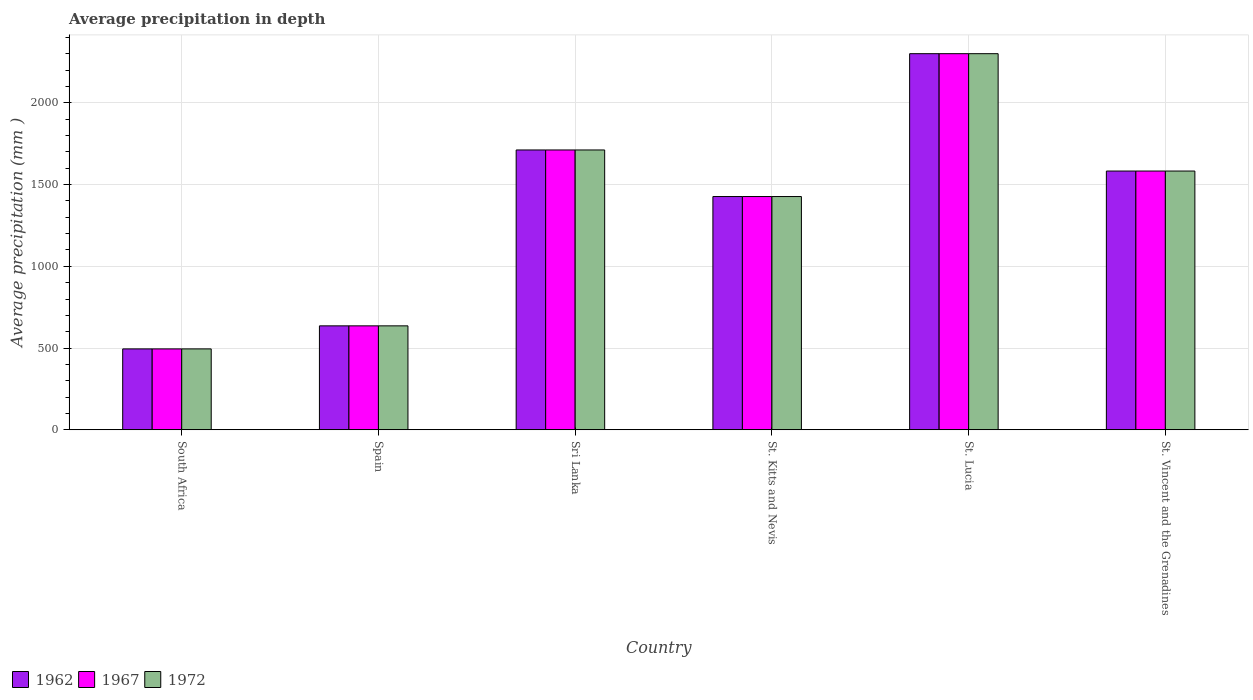How many different coloured bars are there?
Give a very brief answer. 3. How many bars are there on the 6th tick from the left?
Offer a terse response. 3. How many bars are there on the 3rd tick from the right?
Your answer should be compact. 3. What is the label of the 1st group of bars from the left?
Make the answer very short. South Africa. In how many cases, is the number of bars for a given country not equal to the number of legend labels?
Give a very brief answer. 0. What is the average precipitation in 1967 in Sri Lanka?
Provide a succinct answer. 1712. Across all countries, what is the maximum average precipitation in 1967?
Your response must be concise. 2301. Across all countries, what is the minimum average precipitation in 1972?
Ensure brevity in your answer.  495. In which country was the average precipitation in 1967 maximum?
Ensure brevity in your answer.  St. Lucia. In which country was the average precipitation in 1962 minimum?
Your answer should be compact. South Africa. What is the total average precipitation in 1972 in the graph?
Ensure brevity in your answer.  8154. What is the difference between the average precipitation in 1972 in South Africa and that in St. Lucia?
Keep it short and to the point. -1806. What is the difference between the average precipitation in 1967 in St. Vincent and the Grenadines and the average precipitation in 1972 in Spain?
Offer a terse response. 947. What is the average average precipitation in 1962 per country?
Provide a succinct answer. 1359. In how many countries, is the average precipitation in 1967 greater than 300 mm?
Provide a short and direct response. 6. What is the ratio of the average precipitation in 1967 in St. Lucia to that in St. Vincent and the Grenadines?
Your answer should be compact. 1.45. Is the difference between the average precipitation in 1972 in South Africa and Spain greater than the difference between the average precipitation in 1967 in South Africa and Spain?
Give a very brief answer. No. What is the difference between the highest and the second highest average precipitation in 1962?
Provide a short and direct response. -589. What is the difference between the highest and the lowest average precipitation in 1962?
Make the answer very short. 1806. Is the sum of the average precipitation in 1962 in Sri Lanka and St. Kitts and Nevis greater than the maximum average precipitation in 1967 across all countries?
Give a very brief answer. Yes. What does the 2nd bar from the right in St. Kitts and Nevis represents?
Your answer should be very brief. 1967. Is it the case that in every country, the sum of the average precipitation in 1962 and average precipitation in 1972 is greater than the average precipitation in 1967?
Provide a succinct answer. Yes. How many bars are there?
Provide a succinct answer. 18. Are all the bars in the graph horizontal?
Your answer should be compact. No. How many countries are there in the graph?
Your answer should be compact. 6. What is the difference between two consecutive major ticks on the Y-axis?
Make the answer very short. 500. Does the graph contain any zero values?
Give a very brief answer. No. Where does the legend appear in the graph?
Offer a very short reply. Bottom left. What is the title of the graph?
Offer a terse response. Average precipitation in depth. Does "1987" appear as one of the legend labels in the graph?
Make the answer very short. No. What is the label or title of the X-axis?
Ensure brevity in your answer.  Country. What is the label or title of the Y-axis?
Offer a terse response. Average precipitation (mm ). What is the Average precipitation (mm ) in 1962 in South Africa?
Provide a short and direct response. 495. What is the Average precipitation (mm ) in 1967 in South Africa?
Your answer should be compact. 495. What is the Average precipitation (mm ) in 1972 in South Africa?
Offer a very short reply. 495. What is the Average precipitation (mm ) of 1962 in Spain?
Your response must be concise. 636. What is the Average precipitation (mm ) in 1967 in Spain?
Ensure brevity in your answer.  636. What is the Average precipitation (mm ) of 1972 in Spain?
Keep it short and to the point. 636. What is the Average precipitation (mm ) of 1962 in Sri Lanka?
Keep it short and to the point. 1712. What is the Average precipitation (mm ) of 1967 in Sri Lanka?
Provide a short and direct response. 1712. What is the Average precipitation (mm ) of 1972 in Sri Lanka?
Offer a very short reply. 1712. What is the Average precipitation (mm ) in 1962 in St. Kitts and Nevis?
Keep it short and to the point. 1427. What is the Average precipitation (mm ) in 1967 in St. Kitts and Nevis?
Give a very brief answer. 1427. What is the Average precipitation (mm ) of 1972 in St. Kitts and Nevis?
Provide a succinct answer. 1427. What is the Average precipitation (mm ) of 1962 in St. Lucia?
Give a very brief answer. 2301. What is the Average precipitation (mm ) of 1967 in St. Lucia?
Your answer should be compact. 2301. What is the Average precipitation (mm ) in 1972 in St. Lucia?
Your answer should be compact. 2301. What is the Average precipitation (mm ) of 1962 in St. Vincent and the Grenadines?
Your answer should be very brief. 1583. What is the Average precipitation (mm ) in 1967 in St. Vincent and the Grenadines?
Make the answer very short. 1583. What is the Average precipitation (mm ) of 1972 in St. Vincent and the Grenadines?
Your response must be concise. 1583. Across all countries, what is the maximum Average precipitation (mm ) of 1962?
Your response must be concise. 2301. Across all countries, what is the maximum Average precipitation (mm ) of 1967?
Offer a very short reply. 2301. Across all countries, what is the maximum Average precipitation (mm ) of 1972?
Give a very brief answer. 2301. Across all countries, what is the minimum Average precipitation (mm ) in 1962?
Offer a very short reply. 495. Across all countries, what is the minimum Average precipitation (mm ) of 1967?
Make the answer very short. 495. Across all countries, what is the minimum Average precipitation (mm ) in 1972?
Offer a terse response. 495. What is the total Average precipitation (mm ) of 1962 in the graph?
Provide a short and direct response. 8154. What is the total Average precipitation (mm ) in 1967 in the graph?
Make the answer very short. 8154. What is the total Average precipitation (mm ) of 1972 in the graph?
Ensure brevity in your answer.  8154. What is the difference between the Average precipitation (mm ) of 1962 in South Africa and that in Spain?
Offer a very short reply. -141. What is the difference between the Average precipitation (mm ) in 1967 in South Africa and that in Spain?
Provide a short and direct response. -141. What is the difference between the Average precipitation (mm ) of 1972 in South Africa and that in Spain?
Give a very brief answer. -141. What is the difference between the Average precipitation (mm ) in 1962 in South Africa and that in Sri Lanka?
Offer a terse response. -1217. What is the difference between the Average precipitation (mm ) of 1967 in South Africa and that in Sri Lanka?
Your answer should be very brief. -1217. What is the difference between the Average precipitation (mm ) in 1972 in South Africa and that in Sri Lanka?
Provide a succinct answer. -1217. What is the difference between the Average precipitation (mm ) of 1962 in South Africa and that in St. Kitts and Nevis?
Give a very brief answer. -932. What is the difference between the Average precipitation (mm ) in 1967 in South Africa and that in St. Kitts and Nevis?
Give a very brief answer. -932. What is the difference between the Average precipitation (mm ) of 1972 in South Africa and that in St. Kitts and Nevis?
Your response must be concise. -932. What is the difference between the Average precipitation (mm ) of 1962 in South Africa and that in St. Lucia?
Make the answer very short. -1806. What is the difference between the Average precipitation (mm ) of 1967 in South Africa and that in St. Lucia?
Your response must be concise. -1806. What is the difference between the Average precipitation (mm ) of 1972 in South Africa and that in St. Lucia?
Make the answer very short. -1806. What is the difference between the Average precipitation (mm ) of 1962 in South Africa and that in St. Vincent and the Grenadines?
Provide a succinct answer. -1088. What is the difference between the Average precipitation (mm ) in 1967 in South Africa and that in St. Vincent and the Grenadines?
Your response must be concise. -1088. What is the difference between the Average precipitation (mm ) of 1972 in South Africa and that in St. Vincent and the Grenadines?
Give a very brief answer. -1088. What is the difference between the Average precipitation (mm ) in 1962 in Spain and that in Sri Lanka?
Provide a short and direct response. -1076. What is the difference between the Average precipitation (mm ) of 1967 in Spain and that in Sri Lanka?
Give a very brief answer. -1076. What is the difference between the Average precipitation (mm ) in 1972 in Spain and that in Sri Lanka?
Ensure brevity in your answer.  -1076. What is the difference between the Average precipitation (mm ) of 1962 in Spain and that in St. Kitts and Nevis?
Give a very brief answer. -791. What is the difference between the Average precipitation (mm ) in 1967 in Spain and that in St. Kitts and Nevis?
Provide a short and direct response. -791. What is the difference between the Average precipitation (mm ) of 1972 in Spain and that in St. Kitts and Nevis?
Your answer should be very brief. -791. What is the difference between the Average precipitation (mm ) in 1962 in Spain and that in St. Lucia?
Keep it short and to the point. -1665. What is the difference between the Average precipitation (mm ) in 1967 in Spain and that in St. Lucia?
Make the answer very short. -1665. What is the difference between the Average precipitation (mm ) in 1972 in Spain and that in St. Lucia?
Your response must be concise. -1665. What is the difference between the Average precipitation (mm ) of 1962 in Spain and that in St. Vincent and the Grenadines?
Your answer should be compact. -947. What is the difference between the Average precipitation (mm ) of 1967 in Spain and that in St. Vincent and the Grenadines?
Keep it short and to the point. -947. What is the difference between the Average precipitation (mm ) in 1972 in Spain and that in St. Vincent and the Grenadines?
Your answer should be very brief. -947. What is the difference between the Average precipitation (mm ) of 1962 in Sri Lanka and that in St. Kitts and Nevis?
Provide a succinct answer. 285. What is the difference between the Average precipitation (mm ) in 1967 in Sri Lanka and that in St. Kitts and Nevis?
Your answer should be compact. 285. What is the difference between the Average precipitation (mm ) in 1972 in Sri Lanka and that in St. Kitts and Nevis?
Keep it short and to the point. 285. What is the difference between the Average precipitation (mm ) in 1962 in Sri Lanka and that in St. Lucia?
Make the answer very short. -589. What is the difference between the Average precipitation (mm ) of 1967 in Sri Lanka and that in St. Lucia?
Provide a short and direct response. -589. What is the difference between the Average precipitation (mm ) in 1972 in Sri Lanka and that in St. Lucia?
Make the answer very short. -589. What is the difference between the Average precipitation (mm ) in 1962 in Sri Lanka and that in St. Vincent and the Grenadines?
Your answer should be very brief. 129. What is the difference between the Average precipitation (mm ) of 1967 in Sri Lanka and that in St. Vincent and the Grenadines?
Offer a terse response. 129. What is the difference between the Average precipitation (mm ) of 1972 in Sri Lanka and that in St. Vincent and the Grenadines?
Ensure brevity in your answer.  129. What is the difference between the Average precipitation (mm ) of 1962 in St. Kitts and Nevis and that in St. Lucia?
Ensure brevity in your answer.  -874. What is the difference between the Average precipitation (mm ) in 1967 in St. Kitts and Nevis and that in St. Lucia?
Your answer should be compact. -874. What is the difference between the Average precipitation (mm ) of 1972 in St. Kitts and Nevis and that in St. Lucia?
Give a very brief answer. -874. What is the difference between the Average precipitation (mm ) in 1962 in St. Kitts and Nevis and that in St. Vincent and the Grenadines?
Ensure brevity in your answer.  -156. What is the difference between the Average precipitation (mm ) in 1967 in St. Kitts and Nevis and that in St. Vincent and the Grenadines?
Provide a succinct answer. -156. What is the difference between the Average precipitation (mm ) in 1972 in St. Kitts and Nevis and that in St. Vincent and the Grenadines?
Make the answer very short. -156. What is the difference between the Average precipitation (mm ) in 1962 in St. Lucia and that in St. Vincent and the Grenadines?
Give a very brief answer. 718. What is the difference between the Average precipitation (mm ) in 1967 in St. Lucia and that in St. Vincent and the Grenadines?
Your answer should be compact. 718. What is the difference between the Average precipitation (mm ) in 1972 in St. Lucia and that in St. Vincent and the Grenadines?
Provide a short and direct response. 718. What is the difference between the Average precipitation (mm ) of 1962 in South Africa and the Average precipitation (mm ) of 1967 in Spain?
Keep it short and to the point. -141. What is the difference between the Average precipitation (mm ) in 1962 in South Africa and the Average precipitation (mm ) in 1972 in Spain?
Your answer should be very brief. -141. What is the difference between the Average precipitation (mm ) of 1967 in South Africa and the Average precipitation (mm ) of 1972 in Spain?
Offer a terse response. -141. What is the difference between the Average precipitation (mm ) in 1962 in South Africa and the Average precipitation (mm ) in 1967 in Sri Lanka?
Your answer should be compact. -1217. What is the difference between the Average precipitation (mm ) in 1962 in South Africa and the Average precipitation (mm ) in 1972 in Sri Lanka?
Your answer should be compact. -1217. What is the difference between the Average precipitation (mm ) of 1967 in South Africa and the Average precipitation (mm ) of 1972 in Sri Lanka?
Your answer should be very brief. -1217. What is the difference between the Average precipitation (mm ) in 1962 in South Africa and the Average precipitation (mm ) in 1967 in St. Kitts and Nevis?
Your response must be concise. -932. What is the difference between the Average precipitation (mm ) of 1962 in South Africa and the Average precipitation (mm ) of 1972 in St. Kitts and Nevis?
Make the answer very short. -932. What is the difference between the Average precipitation (mm ) in 1967 in South Africa and the Average precipitation (mm ) in 1972 in St. Kitts and Nevis?
Give a very brief answer. -932. What is the difference between the Average precipitation (mm ) of 1962 in South Africa and the Average precipitation (mm ) of 1967 in St. Lucia?
Provide a succinct answer. -1806. What is the difference between the Average precipitation (mm ) of 1962 in South Africa and the Average precipitation (mm ) of 1972 in St. Lucia?
Give a very brief answer. -1806. What is the difference between the Average precipitation (mm ) in 1967 in South Africa and the Average precipitation (mm ) in 1972 in St. Lucia?
Your answer should be very brief. -1806. What is the difference between the Average precipitation (mm ) in 1962 in South Africa and the Average precipitation (mm ) in 1967 in St. Vincent and the Grenadines?
Keep it short and to the point. -1088. What is the difference between the Average precipitation (mm ) in 1962 in South Africa and the Average precipitation (mm ) in 1972 in St. Vincent and the Grenadines?
Make the answer very short. -1088. What is the difference between the Average precipitation (mm ) of 1967 in South Africa and the Average precipitation (mm ) of 1972 in St. Vincent and the Grenadines?
Ensure brevity in your answer.  -1088. What is the difference between the Average precipitation (mm ) of 1962 in Spain and the Average precipitation (mm ) of 1967 in Sri Lanka?
Provide a short and direct response. -1076. What is the difference between the Average precipitation (mm ) in 1962 in Spain and the Average precipitation (mm ) in 1972 in Sri Lanka?
Ensure brevity in your answer.  -1076. What is the difference between the Average precipitation (mm ) in 1967 in Spain and the Average precipitation (mm ) in 1972 in Sri Lanka?
Ensure brevity in your answer.  -1076. What is the difference between the Average precipitation (mm ) in 1962 in Spain and the Average precipitation (mm ) in 1967 in St. Kitts and Nevis?
Offer a terse response. -791. What is the difference between the Average precipitation (mm ) in 1962 in Spain and the Average precipitation (mm ) in 1972 in St. Kitts and Nevis?
Your answer should be very brief. -791. What is the difference between the Average precipitation (mm ) of 1967 in Spain and the Average precipitation (mm ) of 1972 in St. Kitts and Nevis?
Your answer should be very brief. -791. What is the difference between the Average precipitation (mm ) in 1962 in Spain and the Average precipitation (mm ) in 1967 in St. Lucia?
Your answer should be compact. -1665. What is the difference between the Average precipitation (mm ) in 1962 in Spain and the Average precipitation (mm ) in 1972 in St. Lucia?
Make the answer very short. -1665. What is the difference between the Average precipitation (mm ) in 1967 in Spain and the Average precipitation (mm ) in 1972 in St. Lucia?
Provide a short and direct response. -1665. What is the difference between the Average precipitation (mm ) in 1962 in Spain and the Average precipitation (mm ) in 1967 in St. Vincent and the Grenadines?
Your response must be concise. -947. What is the difference between the Average precipitation (mm ) of 1962 in Spain and the Average precipitation (mm ) of 1972 in St. Vincent and the Grenadines?
Make the answer very short. -947. What is the difference between the Average precipitation (mm ) in 1967 in Spain and the Average precipitation (mm ) in 1972 in St. Vincent and the Grenadines?
Your response must be concise. -947. What is the difference between the Average precipitation (mm ) of 1962 in Sri Lanka and the Average precipitation (mm ) of 1967 in St. Kitts and Nevis?
Provide a short and direct response. 285. What is the difference between the Average precipitation (mm ) of 1962 in Sri Lanka and the Average precipitation (mm ) of 1972 in St. Kitts and Nevis?
Your answer should be compact. 285. What is the difference between the Average precipitation (mm ) in 1967 in Sri Lanka and the Average precipitation (mm ) in 1972 in St. Kitts and Nevis?
Provide a short and direct response. 285. What is the difference between the Average precipitation (mm ) in 1962 in Sri Lanka and the Average precipitation (mm ) in 1967 in St. Lucia?
Your answer should be compact. -589. What is the difference between the Average precipitation (mm ) of 1962 in Sri Lanka and the Average precipitation (mm ) of 1972 in St. Lucia?
Your response must be concise. -589. What is the difference between the Average precipitation (mm ) in 1967 in Sri Lanka and the Average precipitation (mm ) in 1972 in St. Lucia?
Give a very brief answer. -589. What is the difference between the Average precipitation (mm ) of 1962 in Sri Lanka and the Average precipitation (mm ) of 1967 in St. Vincent and the Grenadines?
Give a very brief answer. 129. What is the difference between the Average precipitation (mm ) of 1962 in Sri Lanka and the Average precipitation (mm ) of 1972 in St. Vincent and the Grenadines?
Your answer should be very brief. 129. What is the difference between the Average precipitation (mm ) of 1967 in Sri Lanka and the Average precipitation (mm ) of 1972 in St. Vincent and the Grenadines?
Provide a short and direct response. 129. What is the difference between the Average precipitation (mm ) of 1962 in St. Kitts and Nevis and the Average precipitation (mm ) of 1967 in St. Lucia?
Keep it short and to the point. -874. What is the difference between the Average precipitation (mm ) in 1962 in St. Kitts and Nevis and the Average precipitation (mm ) in 1972 in St. Lucia?
Provide a succinct answer. -874. What is the difference between the Average precipitation (mm ) of 1967 in St. Kitts and Nevis and the Average precipitation (mm ) of 1972 in St. Lucia?
Offer a terse response. -874. What is the difference between the Average precipitation (mm ) in 1962 in St. Kitts and Nevis and the Average precipitation (mm ) in 1967 in St. Vincent and the Grenadines?
Your answer should be compact. -156. What is the difference between the Average precipitation (mm ) in 1962 in St. Kitts and Nevis and the Average precipitation (mm ) in 1972 in St. Vincent and the Grenadines?
Ensure brevity in your answer.  -156. What is the difference between the Average precipitation (mm ) in 1967 in St. Kitts and Nevis and the Average precipitation (mm ) in 1972 in St. Vincent and the Grenadines?
Your answer should be very brief. -156. What is the difference between the Average precipitation (mm ) of 1962 in St. Lucia and the Average precipitation (mm ) of 1967 in St. Vincent and the Grenadines?
Provide a short and direct response. 718. What is the difference between the Average precipitation (mm ) of 1962 in St. Lucia and the Average precipitation (mm ) of 1972 in St. Vincent and the Grenadines?
Your answer should be very brief. 718. What is the difference between the Average precipitation (mm ) of 1967 in St. Lucia and the Average precipitation (mm ) of 1972 in St. Vincent and the Grenadines?
Provide a short and direct response. 718. What is the average Average precipitation (mm ) of 1962 per country?
Make the answer very short. 1359. What is the average Average precipitation (mm ) in 1967 per country?
Ensure brevity in your answer.  1359. What is the average Average precipitation (mm ) of 1972 per country?
Keep it short and to the point. 1359. What is the difference between the Average precipitation (mm ) in 1962 and Average precipitation (mm ) in 1972 in Spain?
Offer a very short reply. 0. What is the difference between the Average precipitation (mm ) of 1967 and Average precipitation (mm ) of 1972 in Spain?
Provide a short and direct response. 0. What is the difference between the Average precipitation (mm ) of 1962 and Average precipitation (mm ) of 1972 in Sri Lanka?
Provide a succinct answer. 0. What is the difference between the Average precipitation (mm ) in 1967 and Average precipitation (mm ) in 1972 in St. Kitts and Nevis?
Make the answer very short. 0. What is the difference between the Average precipitation (mm ) in 1962 and Average precipitation (mm ) in 1972 in St. Vincent and the Grenadines?
Your answer should be compact. 0. What is the difference between the Average precipitation (mm ) of 1967 and Average precipitation (mm ) of 1972 in St. Vincent and the Grenadines?
Ensure brevity in your answer.  0. What is the ratio of the Average precipitation (mm ) of 1962 in South Africa to that in Spain?
Your answer should be compact. 0.78. What is the ratio of the Average precipitation (mm ) in 1967 in South Africa to that in Spain?
Your answer should be very brief. 0.78. What is the ratio of the Average precipitation (mm ) in 1972 in South Africa to that in Spain?
Your response must be concise. 0.78. What is the ratio of the Average precipitation (mm ) in 1962 in South Africa to that in Sri Lanka?
Offer a very short reply. 0.29. What is the ratio of the Average precipitation (mm ) of 1967 in South Africa to that in Sri Lanka?
Make the answer very short. 0.29. What is the ratio of the Average precipitation (mm ) in 1972 in South Africa to that in Sri Lanka?
Provide a succinct answer. 0.29. What is the ratio of the Average precipitation (mm ) in 1962 in South Africa to that in St. Kitts and Nevis?
Offer a very short reply. 0.35. What is the ratio of the Average precipitation (mm ) in 1967 in South Africa to that in St. Kitts and Nevis?
Offer a very short reply. 0.35. What is the ratio of the Average precipitation (mm ) in 1972 in South Africa to that in St. Kitts and Nevis?
Keep it short and to the point. 0.35. What is the ratio of the Average precipitation (mm ) of 1962 in South Africa to that in St. Lucia?
Make the answer very short. 0.22. What is the ratio of the Average precipitation (mm ) in 1967 in South Africa to that in St. Lucia?
Ensure brevity in your answer.  0.22. What is the ratio of the Average precipitation (mm ) in 1972 in South Africa to that in St. Lucia?
Ensure brevity in your answer.  0.22. What is the ratio of the Average precipitation (mm ) in 1962 in South Africa to that in St. Vincent and the Grenadines?
Your answer should be very brief. 0.31. What is the ratio of the Average precipitation (mm ) in 1967 in South Africa to that in St. Vincent and the Grenadines?
Make the answer very short. 0.31. What is the ratio of the Average precipitation (mm ) of 1972 in South Africa to that in St. Vincent and the Grenadines?
Provide a short and direct response. 0.31. What is the ratio of the Average precipitation (mm ) of 1962 in Spain to that in Sri Lanka?
Give a very brief answer. 0.37. What is the ratio of the Average precipitation (mm ) of 1967 in Spain to that in Sri Lanka?
Your response must be concise. 0.37. What is the ratio of the Average precipitation (mm ) of 1972 in Spain to that in Sri Lanka?
Make the answer very short. 0.37. What is the ratio of the Average precipitation (mm ) in 1962 in Spain to that in St. Kitts and Nevis?
Keep it short and to the point. 0.45. What is the ratio of the Average precipitation (mm ) of 1967 in Spain to that in St. Kitts and Nevis?
Make the answer very short. 0.45. What is the ratio of the Average precipitation (mm ) in 1972 in Spain to that in St. Kitts and Nevis?
Provide a succinct answer. 0.45. What is the ratio of the Average precipitation (mm ) in 1962 in Spain to that in St. Lucia?
Offer a terse response. 0.28. What is the ratio of the Average precipitation (mm ) of 1967 in Spain to that in St. Lucia?
Your answer should be compact. 0.28. What is the ratio of the Average precipitation (mm ) of 1972 in Spain to that in St. Lucia?
Ensure brevity in your answer.  0.28. What is the ratio of the Average precipitation (mm ) in 1962 in Spain to that in St. Vincent and the Grenadines?
Your response must be concise. 0.4. What is the ratio of the Average precipitation (mm ) in 1967 in Spain to that in St. Vincent and the Grenadines?
Keep it short and to the point. 0.4. What is the ratio of the Average precipitation (mm ) of 1972 in Spain to that in St. Vincent and the Grenadines?
Your answer should be compact. 0.4. What is the ratio of the Average precipitation (mm ) in 1962 in Sri Lanka to that in St. Kitts and Nevis?
Provide a succinct answer. 1.2. What is the ratio of the Average precipitation (mm ) in 1967 in Sri Lanka to that in St. Kitts and Nevis?
Provide a succinct answer. 1.2. What is the ratio of the Average precipitation (mm ) in 1972 in Sri Lanka to that in St. Kitts and Nevis?
Make the answer very short. 1.2. What is the ratio of the Average precipitation (mm ) of 1962 in Sri Lanka to that in St. Lucia?
Your answer should be compact. 0.74. What is the ratio of the Average precipitation (mm ) in 1967 in Sri Lanka to that in St. Lucia?
Keep it short and to the point. 0.74. What is the ratio of the Average precipitation (mm ) in 1972 in Sri Lanka to that in St. Lucia?
Keep it short and to the point. 0.74. What is the ratio of the Average precipitation (mm ) in 1962 in Sri Lanka to that in St. Vincent and the Grenadines?
Offer a very short reply. 1.08. What is the ratio of the Average precipitation (mm ) in 1967 in Sri Lanka to that in St. Vincent and the Grenadines?
Offer a terse response. 1.08. What is the ratio of the Average precipitation (mm ) of 1972 in Sri Lanka to that in St. Vincent and the Grenadines?
Provide a short and direct response. 1.08. What is the ratio of the Average precipitation (mm ) of 1962 in St. Kitts and Nevis to that in St. Lucia?
Make the answer very short. 0.62. What is the ratio of the Average precipitation (mm ) of 1967 in St. Kitts and Nevis to that in St. Lucia?
Offer a very short reply. 0.62. What is the ratio of the Average precipitation (mm ) in 1972 in St. Kitts and Nevis to that in St. Lucia?
Ensure brevity in your answer.  0.62. What is the ratio of the Average precipitation (mm ) of 1962 in St. Kitts and Nevis to that in St. Vincent and the Grenadines?
Offer a very short reply. 0.9. What is the ratio of the Average precipitation (mm ) in 1967 in St. Kitts and Nevis to that in St. Vincent and the Grenadines?
Ensure brevity in your answer.  0.9. What is the ratio of the Average precipitation (mm ) of 1972 in St. Kitts and Nevis to that in St. Vincent and the Grenadines?
Ensure brevity in your answer.  0.9. What is the ratio of the Average precipitation (mm ) in 1962 in St. Lucia to that in St. Vincent and the Grenadines?
Provide a short and direct response. 1.45. What is the ratio of the Average precipitation (mm ) of 1967 in St. Lucia to that in St. Vincent and the Grenadines?
Give a very brief answer. 1.45. What is the ratio of the Average precipitation (mm ) of 1972 in St. Lucia to that in St. Vincent and the Grenadines?
Your answer should be very brief. 1.45. What is the difference between the highest and the second highest Average precipitation (mm ) of 1962?
Provide a succinct answer. 589. What is the difference between the highest and the second highest Average precipitation (mm ) of 1967?
Ensure brevity in your answer.  589. What is the difference between the highest and the second highest Average precipitation (mm ) of 1972?
Give a very brief answer. 589. What is the difference between the highest and the lowest Average precipitation (mm ) of 1962?
Ensure brevity in your answer.  1806. What is the difference between the highest and the lowest Average precipitation (mm ) of 1967?
Your response must be concise. 1806. What is the difference between the highest and the lowest Average precipitation (mm ) in 1972?
Give a very brief answer. 1806. 